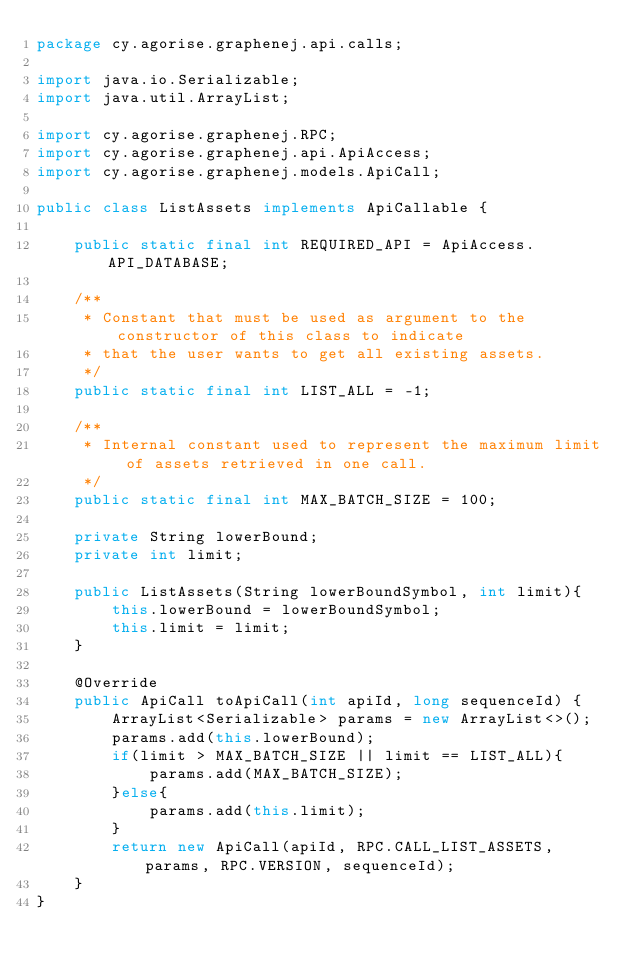<code> <loc_0><loc_0><loc_500><loc_500><_Java_>package cy.agorise.graphenej.api.calls;

import java.io.Serializable;
import java.util.ArrayList;

import cy.agorise.graphenej.RPC;
import cy.agorise.graphenej.api.ApiAccess;
import cy.agorise.graphenej.models.ApiCall;

public class ListAssets implements ApiCallable {

    public static final int REQUIRED_API = ApiAccess.API_DATABASE;

    /**
     * Constant that must be used as argument to the constructor of this class to indicate
     * that the user wants to get all existing assets.
     */
    public static final int LIST_ALL = -1;

    /**
     * Internal constant used to represent the maximum limit of assets retrieved in one call.
     */
    public static final int MAX_BATCH_SIZE = 100;

    private String lowerBound;
    private int limit;

    public ListAssets(String lowerBoundSymbol, int limit){
        this.lowerBound = lowerBoundSymbol;
        this.limit = limit;
    }

    @Override
    public ApiCall toApiCall(int apiId, long sequenceId) {
        ArrayList<Serializable> params = new ArrayList<>();
        params.add(this.lowerBound);
        if(limit > MAX_BATCH_SIZE || limit == LIST_ALL){
            params.add(MAX_BATCH_SIZE);
        }else{
            params.add(this.limit);
        }
        return new ApiCall(apiId, RPC.CALL_LIST_ASSETS, params, RPC.VERSION, sequenceId);
    }
}
</code> 